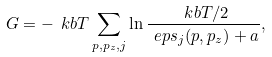<formula> <loc_0><loc_0><loc_500><loc_500>G = - \ k b T \sum _ { { p } , p _ { z } , j } \ln \frac { \ k b T / 2 } { \ e p s _ { j } ( { p } , p _ { z } ) + a } ,</formula> 